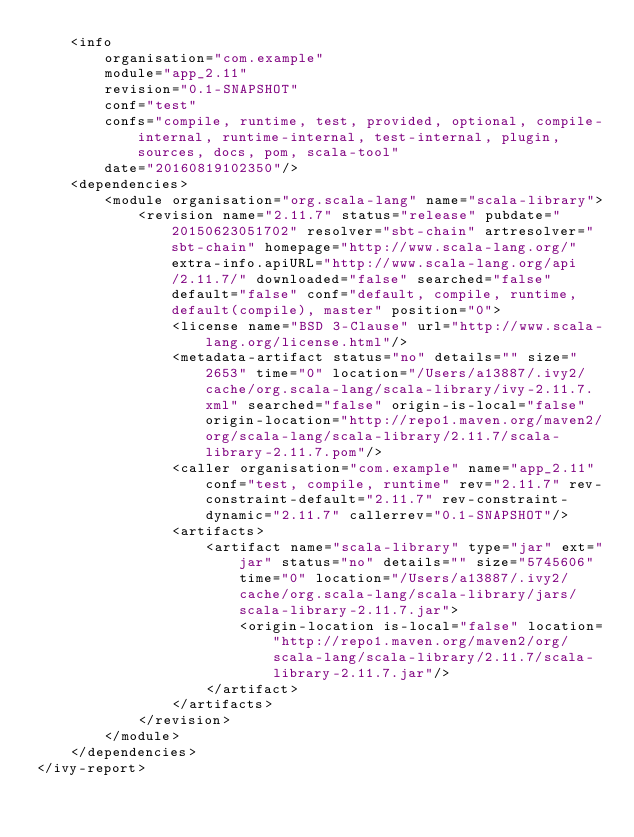Convert code to text. <code><loc_0><loc_0><loc_500><loc_500><_XML_>	<info
		organisation="com.example"
		module="app_2.11"
		revision="0.1-SNAPSHOT"
		conf="test"
		confs="compile, runtime, test, provided, optional, compile-internal, runtime-internal, test-internal, plugin, sources, docs, pom, scala-tool"
		date="20160819102350"/>
	<dependencies>
		<module organisation="org.scala-lang" name="scala-library">
			<revision name="2.11.7" status="release" pubdate="20150623051702" resolver="sbt-chain" artresolver="sbt-chain" homepage="http://www.scala-lang.org/" extra-info.apiURL="http://www.scala-lang.org/api/2.11.7/" downloaded="false" searched="false" default="false" conf="default, compile, runtime, default(compile), master" position="0">
				<license name="BSD 3-Clause" url="http://www.scala-lang.org/license.html"/>
				<metadata-artifact status="no" details="" size="2653" time="0" location="/Users/a13887/.ivy2/cache/org.scala-lang/scala-library/ivy-2.11.7.xml" searched="false" origin-is-local="false" origin-location="http://repo1.maven.org/maven2/org/scala-lang/scala-library/2.11.7/scala-library-2.11.7.pom"/>
				<caller organisation="com.example" name="app_2.11" conf="test, compile, runtime" rev="2.11.7" rev-constraint-default="2.11.7" rev-constraint-dynamic="2.11.7" callerrev="0.1-SNAPSHOT"/>
				<artifacts>
					<artifact name="scala-library" type="jar" ext="jar" status="no" details="" size="5745606" time="0" location="/Users/a13887/.ivy2/cache/org.scala-lang/scala-library/jars/scala-library-2.11.7.jar">
						<origin-location is-local="false" location="http://repo1.maven.org/maven2/org/scala-lang/scala-library/2.11.7/scala-library-2.11.7.jar"/>
					</artifact>
				</artifacts>
			</revision>
		</module>
	</dependencies>
</ivy-report>
</code> 